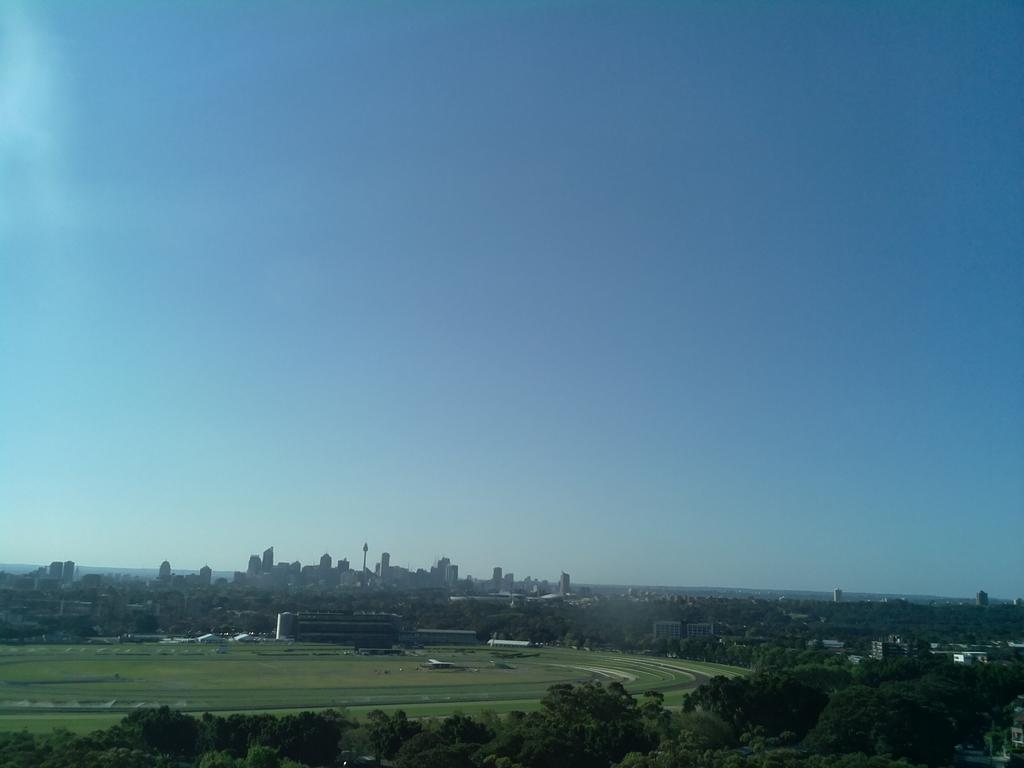What type of natural elements can be seen in the image? There are trees in the image. What type of man-made structures are present in the image? There are buildings in the image. What part of the natural environment is visible in the image? The sky is visible in the image. What type of soda is being served at the minister's time in the image? There is no soda, minister, or time mentioned in the image; it only features trees, buildings, and the sky. 